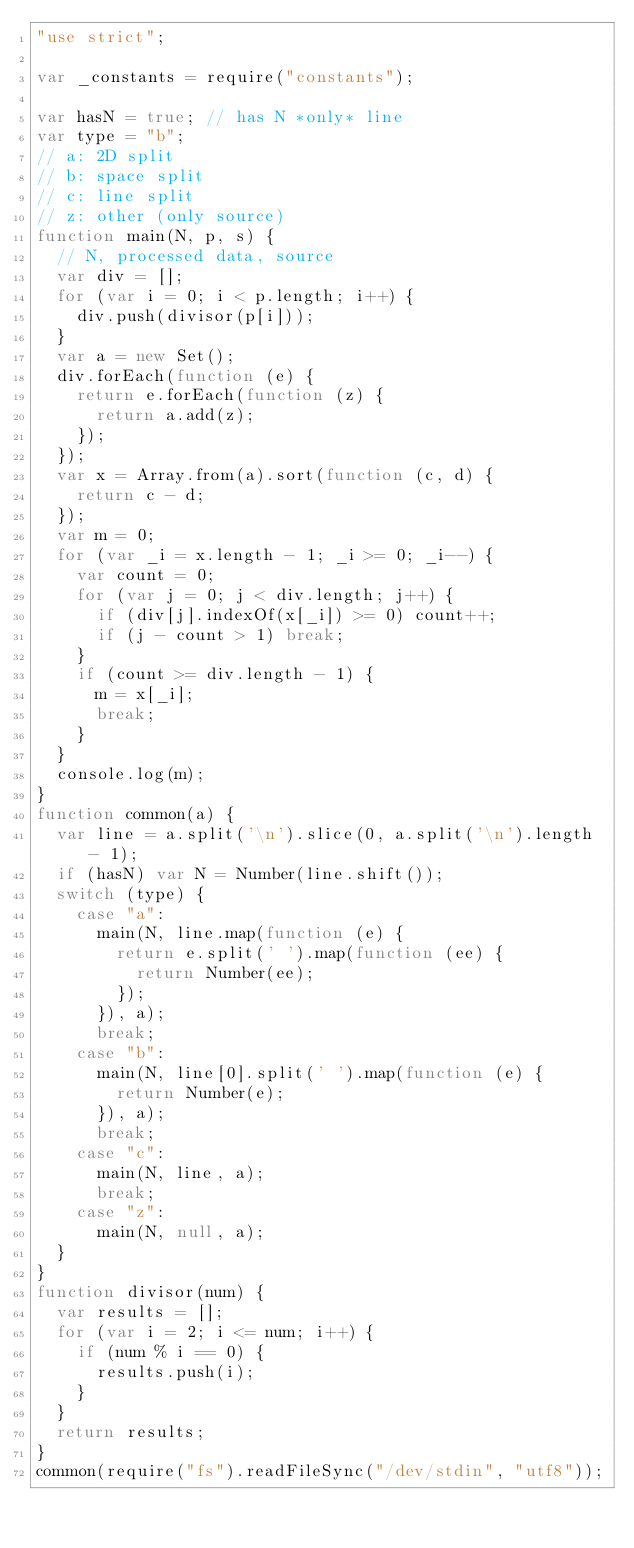<code> <loc_0><loc_0><loc_500><loc_500><_JavaScript_>"use strict";

var _constants = require("constants");

var hasN = true; // has N *only* line
var type = "b";
// a: 2D split
// b: space split
// c: line split
// z: other (only source)
function main(N, p, s) {
  // N, processed data, source
  var div = [];
  for (var i = 0; i < p.length; i++) {
    div.push(divisor(p[i]));
  }
  var a = new Set();
  div.forEach(function (e) {
    return e.forEach(function (z) {
      return a.add(z);
    });
  });
  var x = Array.from(a).sort(function (c, d) {
    return c - d;
  });
  var m = 0;
  for (var _i = x.length - 1; _i >= 0; _i--) {
    var count = 0;
    for (var j = 0; j < div.length; j++) {
      if (div[j].indexOf(x[_i]) >= 0) count++;
      if (j - count > 1) break;
    }
    if (count >= div.length - 1) {
      m = x[_i];
      break;
    }
  }
  console.log(m);
}
function common(a) {
  var line = a.split('\n').slice(0, a.split('\n').length - 1);
  if (hasN) var N = Number(line.shift());
  switch (type) {
    case "a":
      main(N, line.map(function (e) {
        return e.split(' ').map(function (ee) {
          return Number(ee);
        });
      }), a);
      break;
    case "b":
      main(N, line[0].split(' ').map(function (e) {
        return Number(e);
      }), a);
      break;
    case "c":
      main(N, line, a);
      break;
    case "z":
      main(N, null, a);
  }
}
function divisor(num) {
  var results = [];
  for (var i = 2; i <= num; i++) {
    if (num % i == 0) {
      results.push(i);
    }
  }
  return results;
}
common(require("fs").readFileSync("/dev/stdin", "utf8"));
</code> 